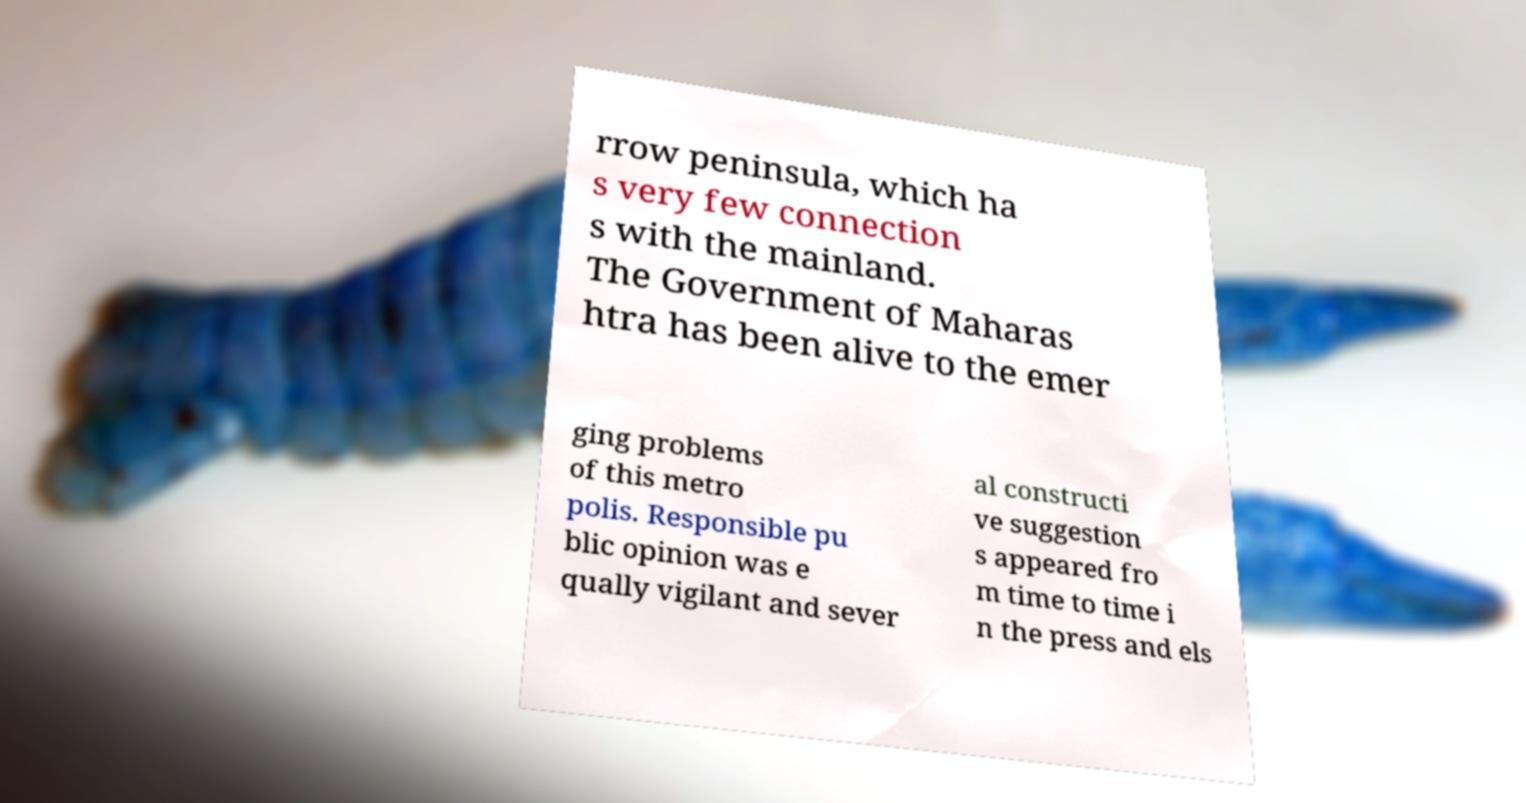Could you assist in decoding the text presented in this image and type it out clearly? rrow peninsula, which ha s very few connection s with the mainland. The Government of Maharas htra has been alive to the emer ging problems of this metro polis. Responsible pu blic opinion was e qually vigilant and sever al constructi ve suggestion s appeared fro m time to time i n the press and els 